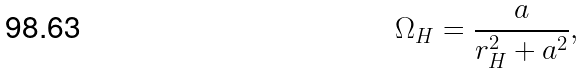<formula> <loc_0><loc_0><loc_500><loc_500>\Omega _ { H } = \frac { a } { r _ { H } ^ { 2 } + a ^ { 2 } } ,</formula> 